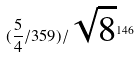<formula> <loc_0><loc_0><loc_500><loc_500>( \frac { 5 } { 4 } / 3 5 9 ) / \sqrt { 8 } ^ { 1 4 6 }</formula> 